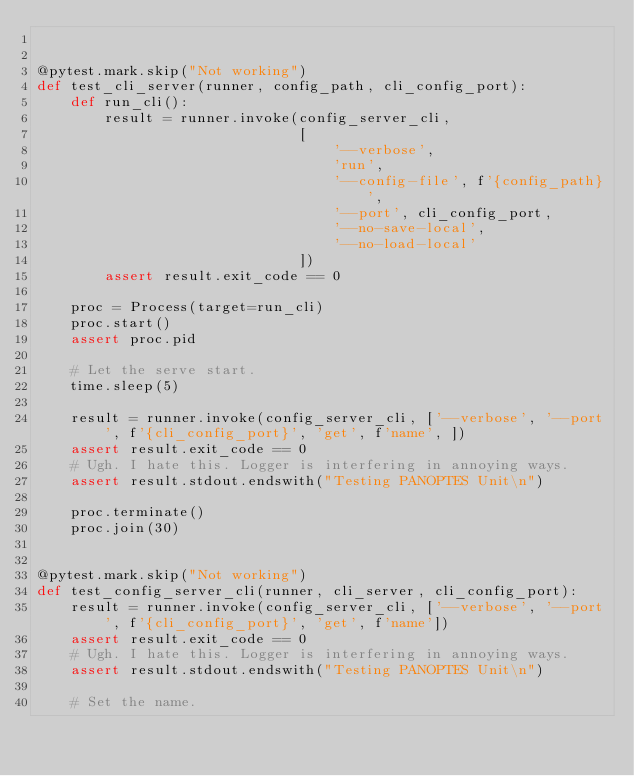Convert code to text. <code><loc_0><loc_0><loc_500><loc_500><_Python_>

@pytest.mark.skip("Not working")
def test_cli_server(runner, config_path, cli_config_port):
    def run_cli():
        result = runner.invoke(config_server_cli,
                               [
                                   '--verbose',
                                   'run',
                                   '--config-file', f'{config_path}',
                                   '--port', cli_config_port,
                                   '--no-save-local',
                                   '--no-load-local'
                               ])
        assert result.exit_code == 0

    proc = Process(target=run_cli)
    proc.start()
    assert proc.pid

    # Let the serve start.
    time.sleep(5)

    result = runner.invoke(config_server_cli, ['--verbose', '--port', f'{cli_config_port}', 'get', f'name', ])
    assert result.exit_code == 0
    # Ugh. I hate this. Logger is interfering in annoying ways.
    assert result.stdout.endswith("Testing PANOPTES Unit\n")

    proc.terminate()
    proc.join(30)


@pytest.mark.skip("Not working")
def test_config_server_cli(runner, cli_server, cli_config_port):
    result = runner.invoke(config_server_cli, ['--verbose', '--port', f'{cli_config_port}', 'get', f'name'])
    assert result.exit_code == 0
    # Ugh. I hate this. Logger is interfering in annoying ways.
    assert result.stdout.endswith("Testing PANOPTES Unit\n")

    # Set the name.</code> 